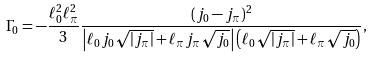<formula> <loc_0><loc_0><loc_500><loc_500>\Gamma _ { 0 } = - \frac { \ell _ { 0 } ^ { 2 } \ell _ { \pi } ^ { 2 } } { 3 } \frac { ( j _ { 0 } - j _ { \pi } ) ^ { 2 } } { \left | \ell _ { 0 } j _ { 0 } \sqrt { | j _ { \pi } | } + \ell _ { \pi } j _ { \pi } \sqrt { j _ { 0 } } \right | \left ( \ell _ { 0 } \sqrt { | j _ { \pi } | } + \ell _ { \pi } \sqrt { j _ { 0 } } \right ) } ,</formula> 